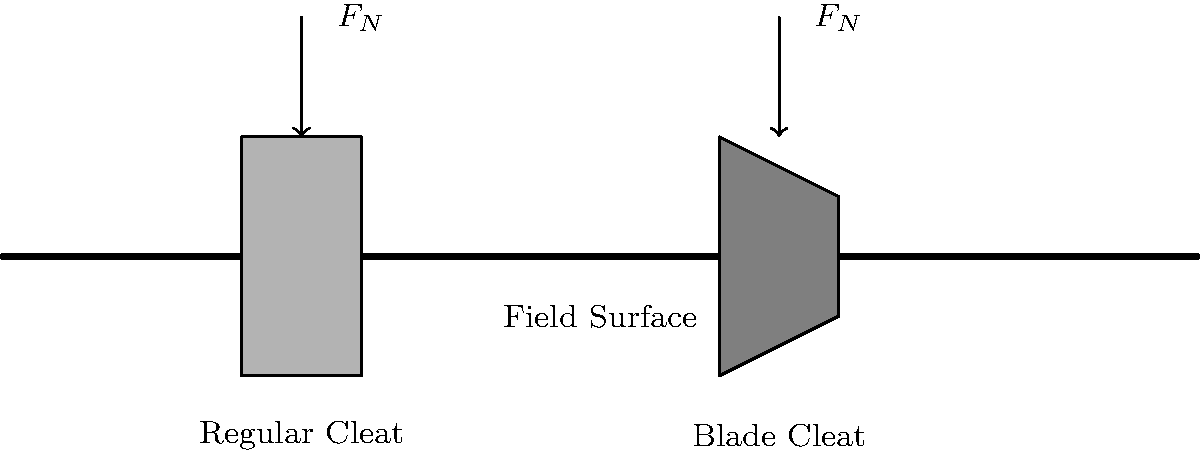Based on the cross-sectional diagram showing two types of cleats (regular and blade) on a field surface, which type of cleat is likely to provide better traction for quick direction changes in youth football, and why? To determine which cleat type provides better traction for quick direction changes, we need to consider the factors affecting friction between the cleat and the field surface:

1. Contact area: The regular cleat has a larger surface area in contact with the ground compared to the blade cleat.

2. Pressure distribution: The regular cleat distributes the normal force ($F_N$) over a larger area, while the blade cleat concentrates it on a smaller area.

3. Friction force: Friction force is given by the equation $F_f = \mu F_N$, where $\mu$ is the coefficient of friction and $F_N$ is the normal force.

4. Penetration: The blade cleat, due to its narrower profile, is more likely to penetrate softer field surfaces.

5. Quick direction changes: These require a combination of good grip and the ability to release quickly from the surface.

Considering these factors:

- The regular cleat provides more stability due to its larger contact area, which is beneficial for maintaining balance during quick movements.
- The blade cleat, while having a smaller contact area, can penetrate the surface more easily, potentially providing better grip on softer fields.
- For quick direction changes, the ability to grip and release quickly is crucial. The blade cleat's design allows for easier entry and exit from the turf, which can be advantageous for rapid movements.
- However, on very hard surfaces, the regular cleat may provide better traction due to its larger contact area.

Given that youth football is often played on various field conditions and quick direction changes are common, the blade cleat is likely to provide better overall performance for most situations.
Answer: Blade cleat, due to better penetration and quicker release for rapid movements. 